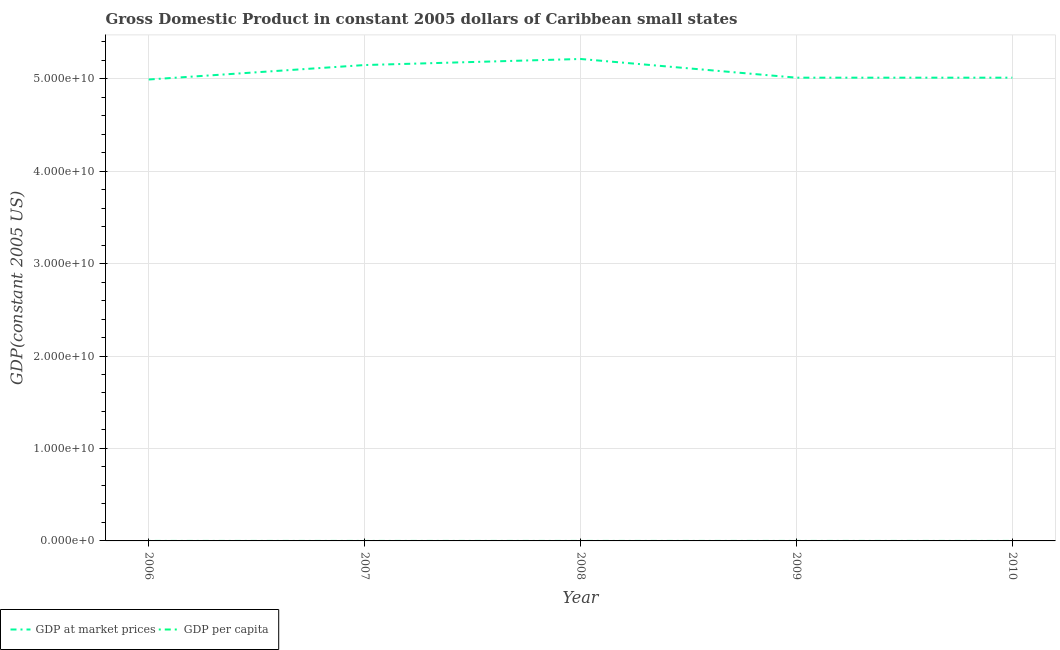How many different coloured lines are there?
Give a very brief answer. 2. Does the line corresponding to gdp at market prices intersect with the line corresponding to gdp per capita?
Your response must be concise. No. What is the gdp per capita in 2009?
Your answer should be very brief. 7356.47. Across all years, what is the maximum gdp per capita?
Your response must be concise. 7703.13. Across all years, what is the minimum gdp per capita?
Offer a terse response. 7309.91. In which year was the gdp at market prices maximum?
Provide a short and direct response. 2008. What is the total gdp per capita in the graph?
Give a very brief answer. 3.75e+04. What is the difference between the gdp at market prices in 2008 and that in 2009?
Make the answer very short. 2.02e+09. What is the difference between the gdp per capita in 2007 and the gdp at market prices in 2008?
Offer a very short reply. -5.21e+1. What is the average gdp per capita per year?
Keep it short and to the point. 7499. In the year 2009, what is the difference between the gdp at market prices and gdp per capita?
Your response must be concise. 5.01e+1. What is the ratio of the gdp at market prices in 2007 to that in 2010?
Ensure brevity in your answer.  1.03. Is the difference between the gdp per capita in 2007 and 2008 greater than the difference between the gdp at market prices in 2007 and 2008?
Provide a succinct answer. Yes. What is the difference between the highest and the second highest gdp at market prices?
Give a very brief answer. 6.56e+08. What is the difference between the highest and the lowest gdp at market prices?
Make the answer very short. 2.22e+09. In how many years, is the gdp per capita greater than the average gdp per capita taken over all years?
Your answer should be compact. 2. Does the gdp per capita monotonically increase over the years?
Make the answer very short. No. Is the gdp at market prices strictly greater than the gdp per capita over the years?
Give a very brief answer. Yes. How many lines are there?
Ensure brevity in your answer.  2. How many years are there in the graph?
Ensure brevity in your answer.  5. Are the values on the major ticks of Y-axis written in scientific E-notation?
Your answer should be very brief. Yes. Does the graph contain grids?
Ensure brevity in your answer.  Yes. How many legend labels are there?
Your response must be concise. 2. What is the title of the graph?
Give a very brief answer. Gross Domestic Product in constant 2005 dollars of Caribbean small states. What is the label or title of the Y-axis?
Ensure brevity in your answer.  GDP(constant 2005 US). What is the GDP(constant 2005 US) in GDP at market prices in 2006?
Make the answer very short. 4.99e+1. What is the GDP(constant 2005 US) of GDP per capita in 2006?
Give a very brief answer. 7469.94. What is the GDP(constant 2005 US) in GDP at market prices in 2007?
Give a very brief answer. 5.15e+1. What is the GDP(constant 2005 US) of GDP per capita in 2007?
Offer a very short reply. 7655.55. What is the GDP(constant 2005 US) of GDP at market prices in 2008?
Your answer should be very brief. 5.21e+1. What is the GDP(constant 2005 US) of GDP per capita in 2008?
Your answer should be compact. 7703.13. What is the GDP(constant 2005 US) of GDP at market prices in 2009?
Give a very brief answer. 5.01e+1. What is the GDP(constant 2005 US) of GDP per capita in 2009?
Your response must be concise. 7356.47. What is the GDP(constant 2005 US) in GDP at market prices in 2010?
Your answer should be compact. 5.01e+1. What is the GDP(constant 2005 US) in GDP per capita in 2010?
Ensure brevity in your answer.  7309.91. Across all years, what is the maximum GDP(constant 2005 US) of GDP at market prices?
Ensure brevity in your answer.  5.21e+1. Across all years, what is the maximum GDP(constant 2005 US) of GDP per capita?
Provide a short and direct response. 7703.13. Across all years, what is the minimum GDP(constant 2005 US) in GDP at market prices?
Provide a succinct answer. 4.99e+1. Across all years, what is the minimum GDP(constant 2005 US) of GDP per capita?
Offer a terse response. 7309.91. What is the total GDP(constant 2005 US) of GDP at market prices in the graph?
Your answer should be very brief. 2.54e+11. What is the total GDP(constant 2005 US) of GDP per capita in the graph?
Make the answer very short. 3.75e+04. What is the difference between the GDP(constant 2005 US) in GDP at market prices in 2006 and that in 2007?
Offer a very short reply. -1.56e+09. What is the difference between the GDP(constant 2005 US) in GDP per capita in 2006 and that in 2007?
Offer a very short reply. -185.61. What is the difference between the GDP(constant 2005 US) of GDP at market prices in 2006 and that in 2008?
Offer a very short reply. -2.22e+09. What is the difference between the GDP(constant 2005 US) in GDP per capita in 2006 and that in 2008?
Provide a short and direct response. -233.19. What is the difference between the GDP(constant 2005 US) in GDP at market prices in 2006 and that in 2009?
Your answer should be compact. -1.98e+08. What is the difference between the GDP(constant 2005 US) in GDP per capita in 2006 and that in 2009?
Provide a succinct answer. 113.47. What is the difference between the GDP(constant 2005 US) in GDP at market prices in 2006 and that in 2010?
Your answer should be very brief. -1.98e+08. What is the difference between the GDP(constant 2005 US) of GDP per capita in 2006 and that in 2010?
Your response must be concise. 160.03. What is the difference between the GDP(constant 2005 US) in GDP at market prices in 2007 and that in 2008?
Provide a succinct answer. -6.56e+08. What is the difference between the GDP(constant 2005 US) of GDP per capita in 2007 and that in 2008?
Your answer should be very brief. -47.58. What is the difference between the GDP(constant 2005 US) of GDP at market prices in 2007 and that in 2009?
Your answer should be very brief. 1.37e+09. What is the difference between the GDP(constant 2005 US) of GDP per capita in 2007 and that in 2009?
Your answer should be very brief. 299.08. What is the difference between the GDP(constant 2005 US) of GDP at market prices in 2007 and that in 2010?
Offer a very short reply. 1.37e+09. What is the difference between the GDP(constant 2005 US) in GDP per capita in 2007 and that in 2010?
Give a very brief answer. 345.64. What is the difference between the GDP(constant 2005 US) in GDP at market prices in 2008 and that in 2009?
Offer a terse response. 2.02e+09. What is the difference between the GDP(constant 2005 US) in GDP per capita in 2008 and that in 2009?
Give a very brief answer. 346.66. What is the difference between the GDP(constant 2005 US) in GDP at market prices in 2008 and that in 2010?
Keep it short and to the point. 2.02e+09. What is the difference between the GDP(constant 2005 US) in GDP per capita in 2008 and that in 2010?
Give a very brief answer. 393.22. What is the difference between the GDP(constant 2005 US) in GDP at market prices in 2009 and that in 2010?
Your response must be concise. 2.06e+05. What is the difference between the GDP(constant 2005 US) in GDP per capita in 2009 and that in 2010?
Your answer should be very brief. 46.56. What is the difference between the GDP(constant 2005 US) of GDP at market prices in 2006 and the GDP(constant 2005 US) of GDP per capita in 2007?
Provide a short and direct response. 4.99e+1. What is the difference between the GDP(constant 2005 US) in GDP at market prices in 2006 and the GDP(constant 2005 US) in GDP per capita in 2008?
Your answer should be compact. 4.99e+1. What is the difference between the GDP(constant 2005 US) in GDP at market prices in 2006 and the GDP(constant 2005 US) in GDP per capita in 2009?
Your answer should be very brief. 4.99e+1. What is the difference between the GDP(constant 2005 US) of GDP at market prices in 2006 and the GDP(constant 2005 US) of GDP per capita in 2010?
Make the answer very short. 4.99e+1. What is the difference between the GDP(constant 2005 US) in GDP at market prices in 2007 and the GDP(constant 2005 US) in GDP per capita in 2008?
Your answer should be very brief. 5.15e+1. What is the difference between the GDP(constant 2005 US) in GDP at market prices in 2007 and the GDP(constant 2005 US) in GDP per capita in 2009?
Your answer should be compact. 5.15e+1. What is the difference between the GDP(constant 2005 US) of GDP at market prices in 2007 and the GDP(constant 2005 US) of GDP per capita in 2010?
Ensure brevity in your answer.  5.15e+1. What is the difference between the GDP(constant 2005 US) of GDP at market prices in 2008 and the GDP(constant 2005 US) of GDP per capita in 2009?
Give a very brief answer. 5.21e+1. What is the difference between the GDP(constant 2005 US) in GDP at market prices in 2008 and the GDP(constant 2005 US) in GDP per capita in 2010?
Give a very brief answer. 5.21e+1. What is the difference between the GDP(constant 2005 US) of GDP at market prices in 2009 and the GDP(constant 2005 US) of GDP per capita in 2010?
Make the answer very short. 5.01e+1. What is the average GDP(constant 2005 US) of GDP at market prices per year?
Offer a very short reply. 5.07e+1. What is the average GDP(constant 2005 US) in GDP per capita per year?
Offer a terse response. 7499. In the year 2006, what is the difference between the GDP(constant 2005 US) of GDP at market prices and GDP(constant 2005 US) of GDP per capita?
Ensure brevity in your answer.  4.99e+1. In the year 2007, what is the difference between the GDP(constant 2005 US) in GDP at market prices and GDP(constant 2005 US) in GDP per capita?
Provide a short and direct response. 5.15e+1. In the year 2008, what is the difference between the GDP(constant 2005 US) in GDP at market prices and GDP(constant 2005 US) in GDP per capita?
Your response must be concise. 5.21e+1. In the year 2009, what is the difference between the GDP(constant 2005 US) in GDP at market prices and GDP(constant 2005 US) in GDP per capita?
Provide a short and direct response. 5.01e+1. In the year 2010, what is the difference between the GDP(constant 2005 US) of GDP at market prices and GDP(constant 2005 US) of GDP per capita?
Your answer should be compact. 5.01e+1. What is the ratio of the GDP(constant 2005 US) of GDP at market prices in 2006 to that in 2007?
Your response must be concise. 0.97. What is the ratio of the GDP(constant 2005 US) of GDP per capita in 2006 to that in 2007?
Offer a very short reply. 0.98. What is the ratio of the GDP(constant 2005 US) in GDP at market prices in 2006 to that in 2008?
Keep it short and to the point. 0.96. What is the ratio of the GDP(constant 2005 US) of GDP per capita in 2006 to that in 2008?
Offer a very short reply. 0.97. What is the ratio of the GDP(constant 2005 US) in GDP per capita in 2006 to that in 2009?
Your response must be concise. 1.02. What is the ratio of the GDP(constant 2005 US) in GDP per capita in 2006 to that in 2010?
Provide a short and direct response. 1.02. What is the ratio of the GDP(constant 2005 US) of GDP at market prices in 2007 to that in 2008?
Give a very brief answer. 0.99. What is the ratio of the GDP(constant 2005 US) of GDP at market prices in 2007 to that in 2009?
Offer a terse response. 1.03. What is the ratio of the GDP(constant 2005 US) of GDP per capita in 2007 to that in 2009?
Your answer should be compact. 1.04. What is the ratio of the GDP(constant 2005 US) in GDP at market prices in 2007 to that in 2010?
Make the answer very short. 1.03. What is the ratio of the GDP(constant 2005 US) in GDP per capita in 2007 to that in 2010?
Your response must be concise. 1.05. What is the ratio of the GDP(constant 2005 US) in GDP at market prices in 2008 to that in 2009?
Offer a very short reply. 1.04. What is the ratio of the GDP(constant 2005 US) in GDP per capita in 2008 to that in 2009?
Give a very brief answer. 1.05. What is the ratio of the GDP(constant 2005 US) in GDP at market prices in 2008 to that in 2010?
Your answer should be very brief. 1.04. What is the ratio of the GDP(constant 2005 US) in GDP per capita in 2008 to that in 2010?
Ensure brevity in your answer.  1.05. What is the ratio of the GDP(constant 2005 US) of GDP at market prices in 2009 to that in 2010?
Your answer should be compact. 1. What is the ratio of the GDP(constant 2005 US) in GDP per capita in 2009 to that in 2010?
Offer a terse response. 1.01. What is the difference between the highest and the second highest GDP(constant 2005 US) of GDP at market prices?
Your response must be concise. 6.56e+08. What is the difference between the highest and the second highest GDP(constant 2005 US) in GDP per capita?
Give a very brief answer. 47.58. What is the difference between the highest and the lowest GDP(constant 2005 US) of GDP at market prices?
Your answer should be compact. 2.22e+09. What is the difference between the highest and the lowest GDP(constant 2005 US) of GDP per capita?
Your answer should be compact. 393.22. 